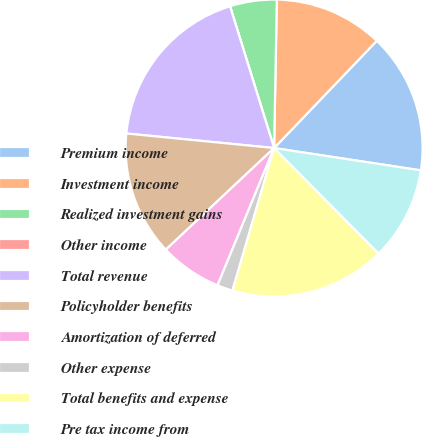Convert chart. <chart><loc_0><loc_0><loc_500><loc_500><pie_chart><fcel>Premium income<fcel>Investment income<fcel>Realized investment gains<fcel>Other income<fcel>Total revenue<fcel>Policyholder benefits<fcel>Amortization of deferred<fcel>Other expense<fcel>Total benefits and expense<fcel>Pre tax income from<nl><fcel>15.25%<fcel>11.86%<fcel>5.09%<fcel>0.0%<fcel>18.64%<fcel>13.56%<fcel>6.78%<fcel>1.7%<fcel>16.95%<fcel>10.17%<nl></chart> 